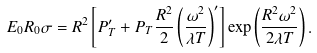<formula> <loc_0><loc_0><loc_500><loc_500>E _ { 0 } R _ { 0 } \sigma = R ^ { 2 } \left [ P _ { T } ^ { \prime } + P _ { T } \frac { R ^ { 2 } } { 2 } \left ( \frac { \omega ^ { 2 } } { \lambda T } \right ) ^ { \prime } \right ] \exp \left ( \frac { R ^ { 2 } \omega ^ { 2 } } { 2 \lambda T } \right ) .</formula> 